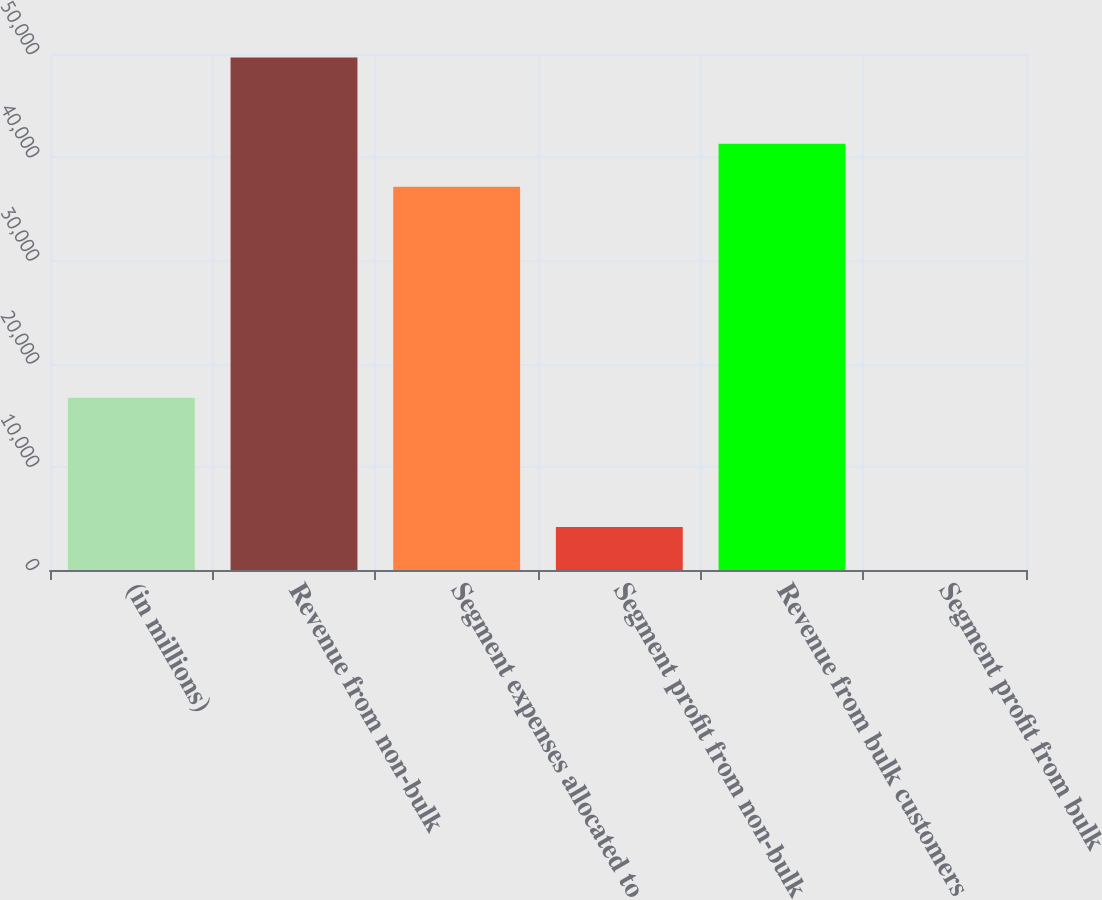Convert chart to OTSL. <chart><loc_0><loc_0><loc_500><loc_500><bar_chart><fcel>(in millions)<fcel>Revenue from non-bulk<fcel>Segment expenses allocated to<fcel>Segment profit from non-bulk<fcel>Revenue from bulk customers<fcel>Segment profit from bulk<nl><fcel>16700.7<fcel>49661.2<fcel>37136<fcel>4175.55<fcel>41311.1<fcel>0.5<nl></chart> 